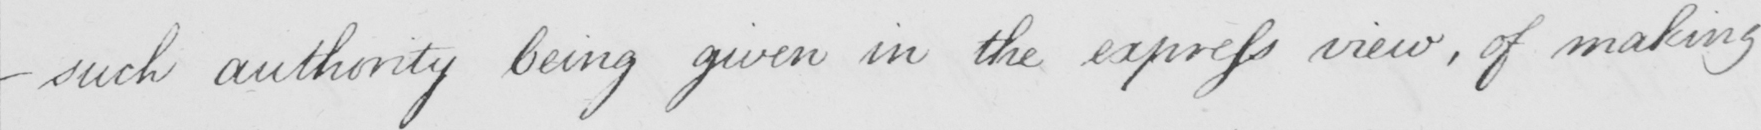What text is written in this handwritten line? _  such authority being given in the express view , of making 